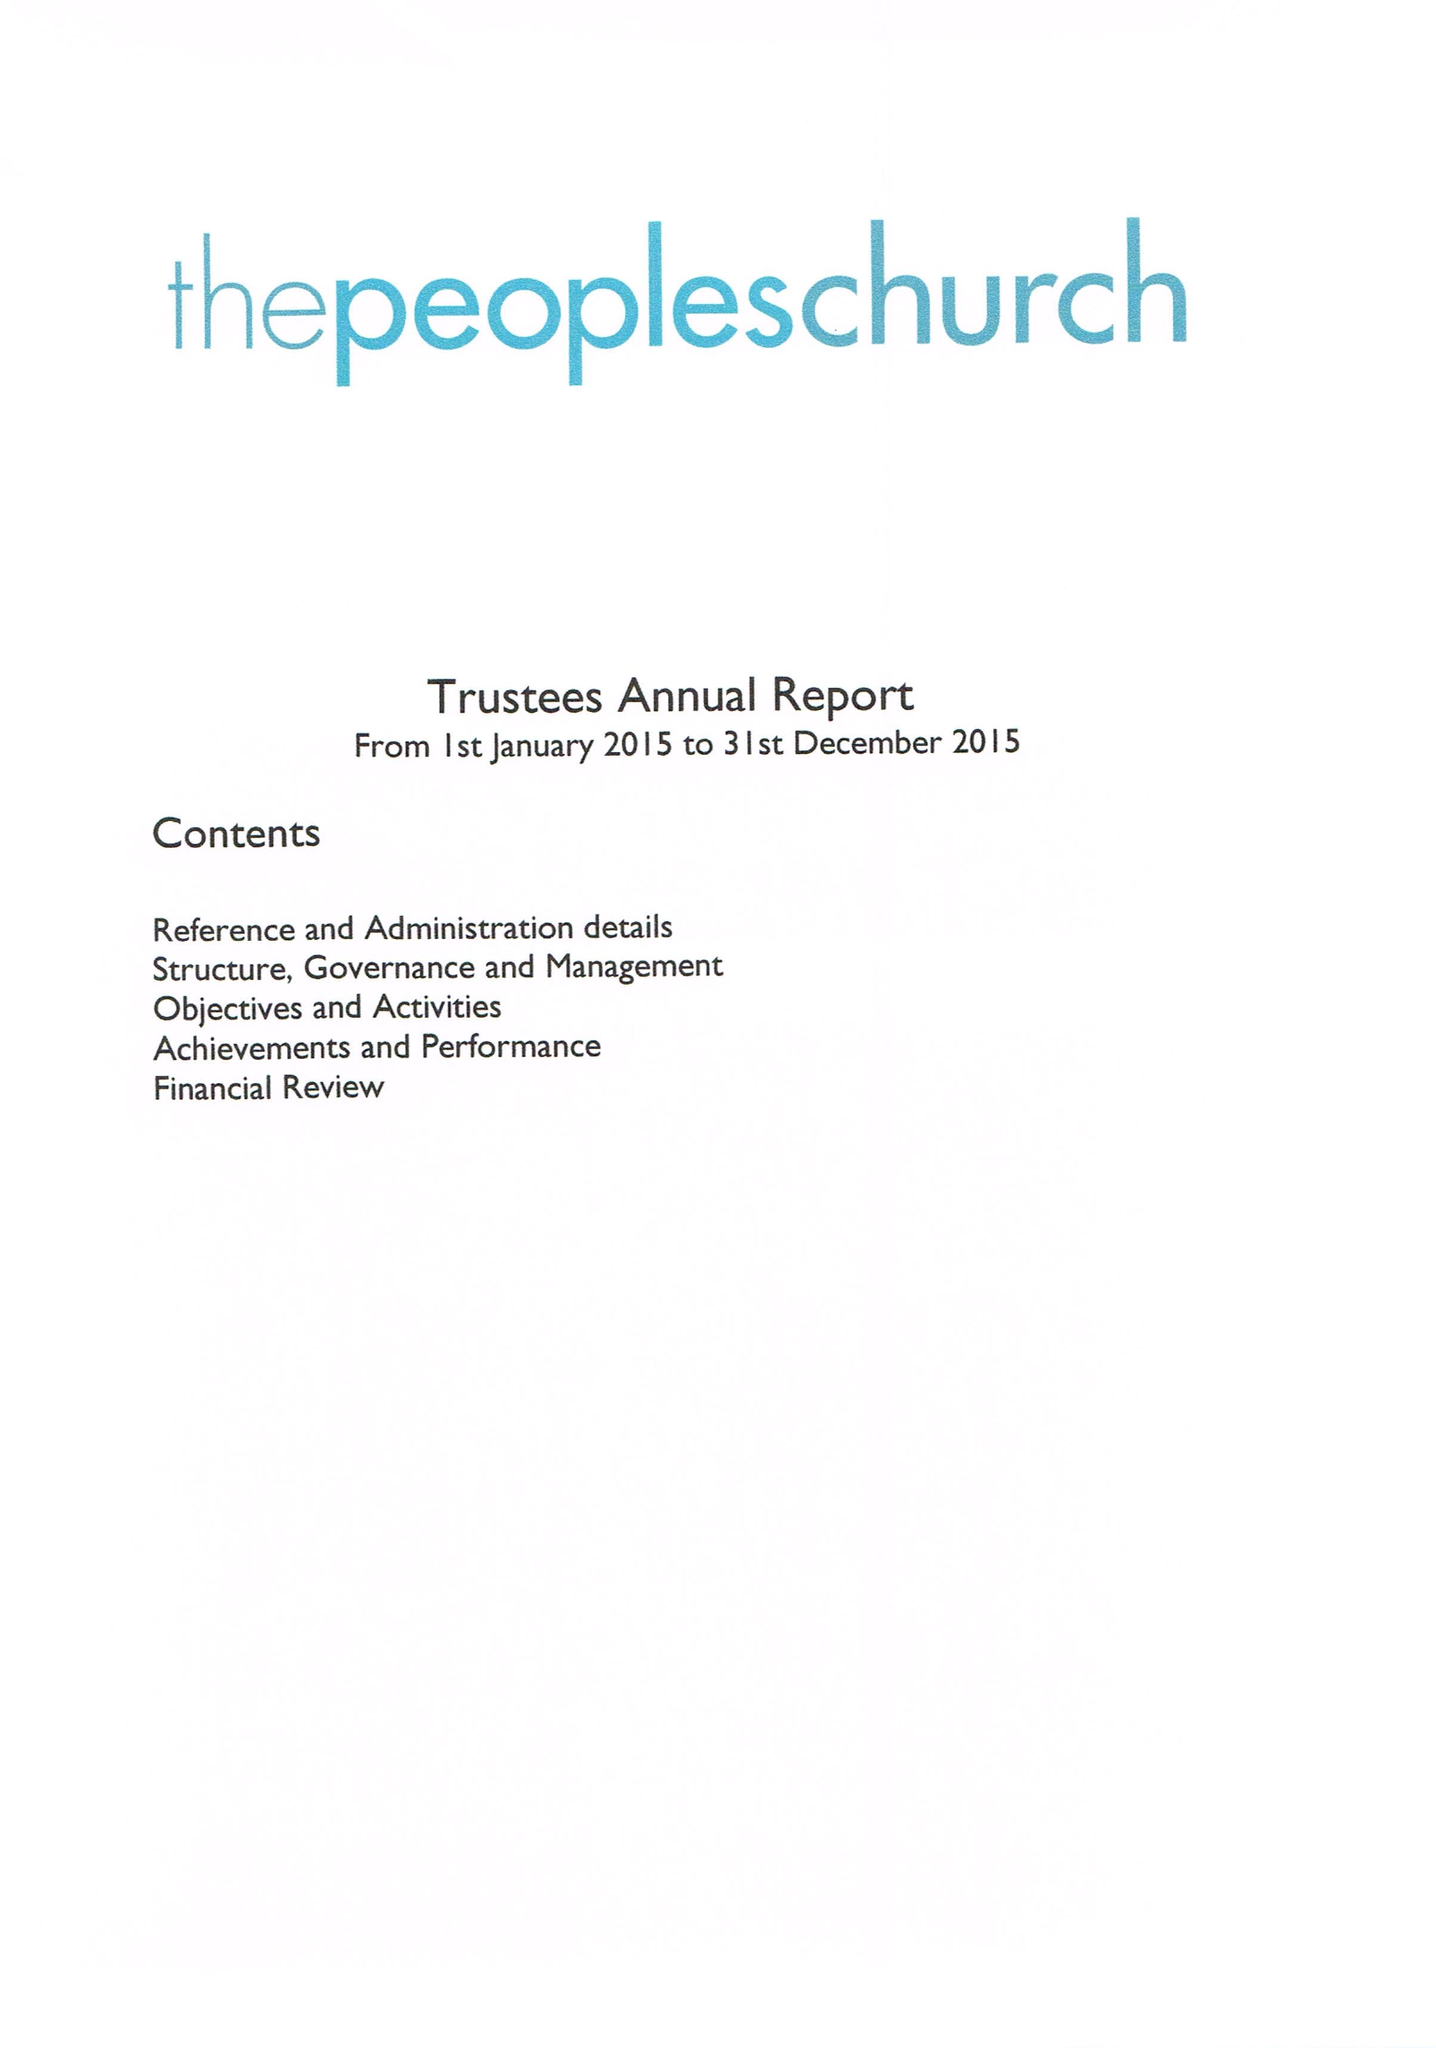What is the value for the spending_annually_in_british_pounds?
Answer the question using a single word or phrase. 164902.00 